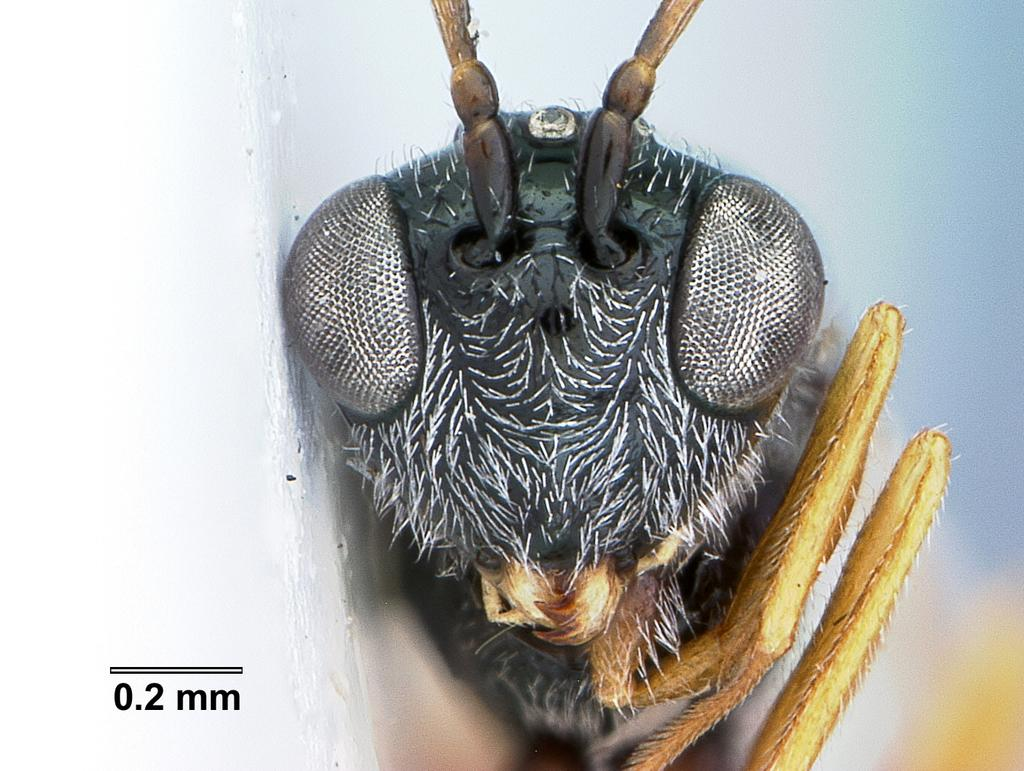What can be seen in the bottom left corner of the image? There is a watermark on the bottom left of the image. What type of creature is present on the right side of the image? There is an ant on the right side of the image. How would you describe the background of the image? The background of the image is blurred. Can you tell me how many parents are visible in the image? There are no parents present in the image. What type of tool is being used by the ant in the image? There is no tool, such as scissors, present in the image. 